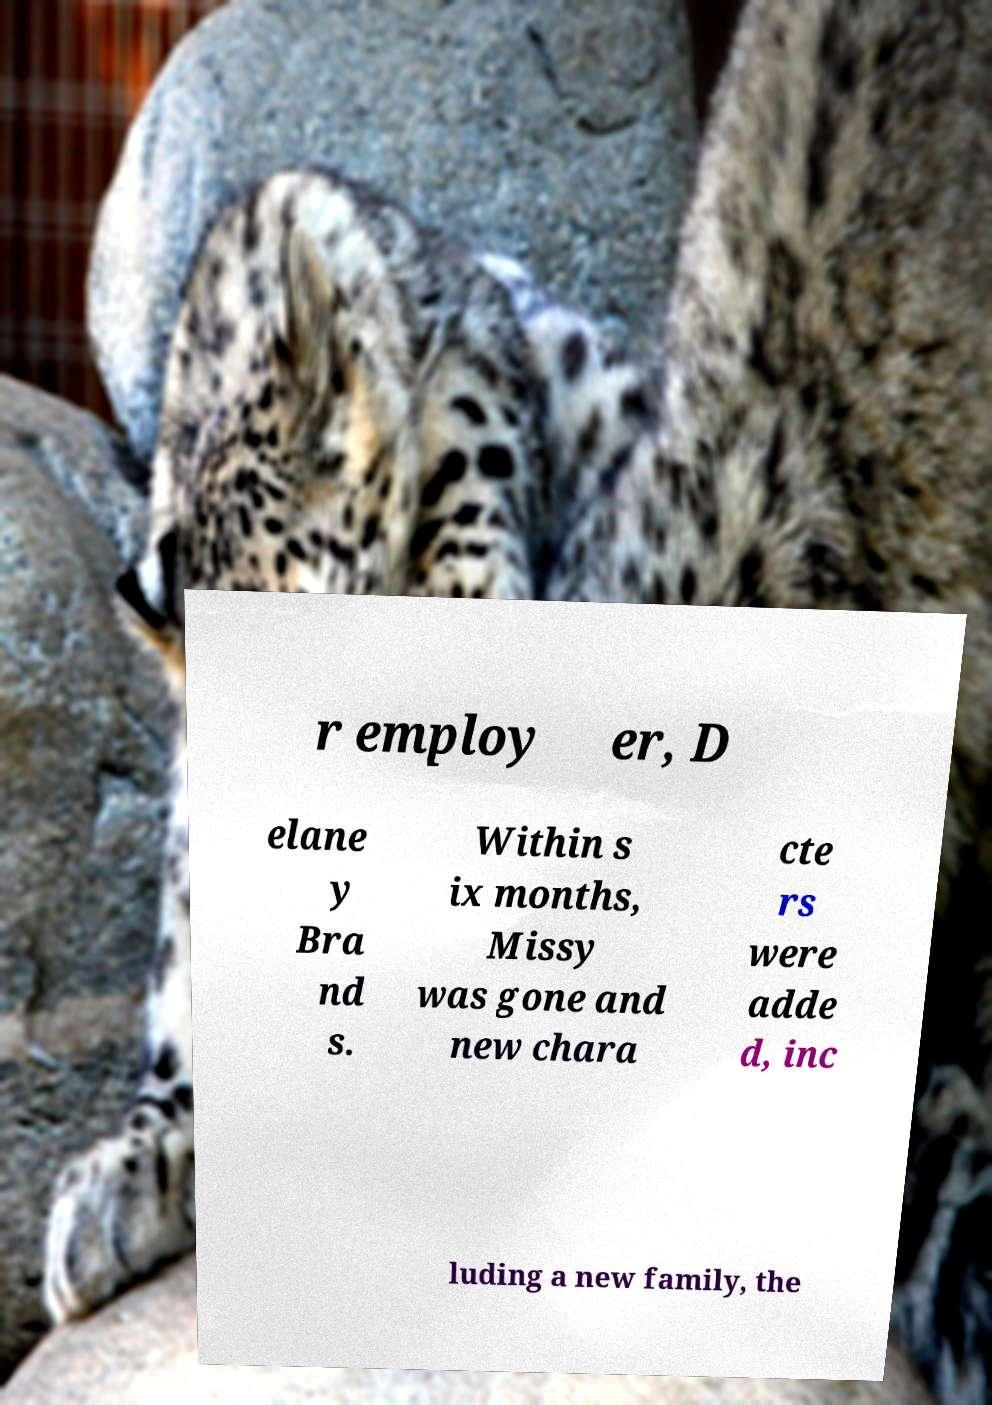For documentation purposes, I need the text within this image transcribed. Could you provide that? r employ er, D elane y Bra nd s. Within s ix months, Missy was gone and new chara cte rs were adde d, inc luding a new family, the 